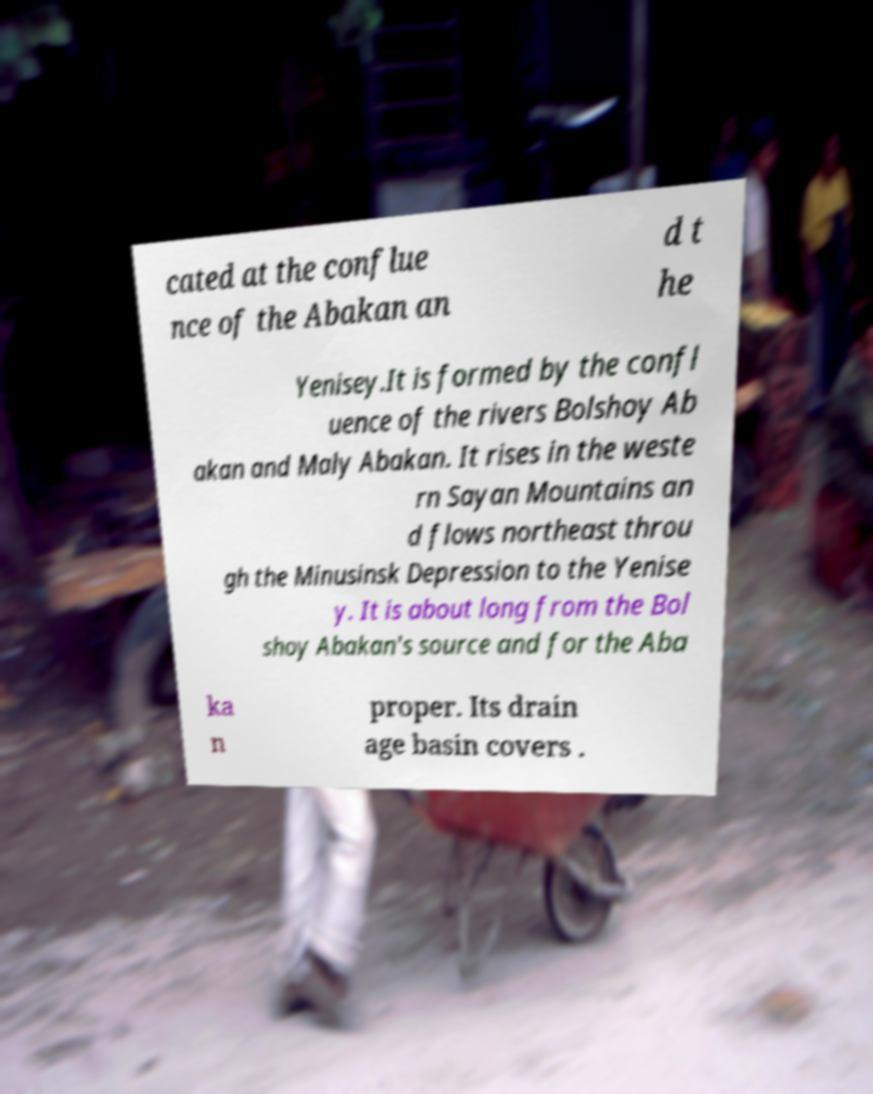Can you accurately transcribe the text from the provided image for me? cated at the conflue nce of the Abakan an d t he Yenisey.It is formed by the confl uence of the rivers Bolshoy Ab akan and Maly Abakan. It rises in the weste rn Sayan Mountains an d flows northeast throu gh the Minusinsk Depression to the Yenise y. It is about long from the Bol shoy Abakan's source and for the Aba ka n proper. Its drain age basin covers . 